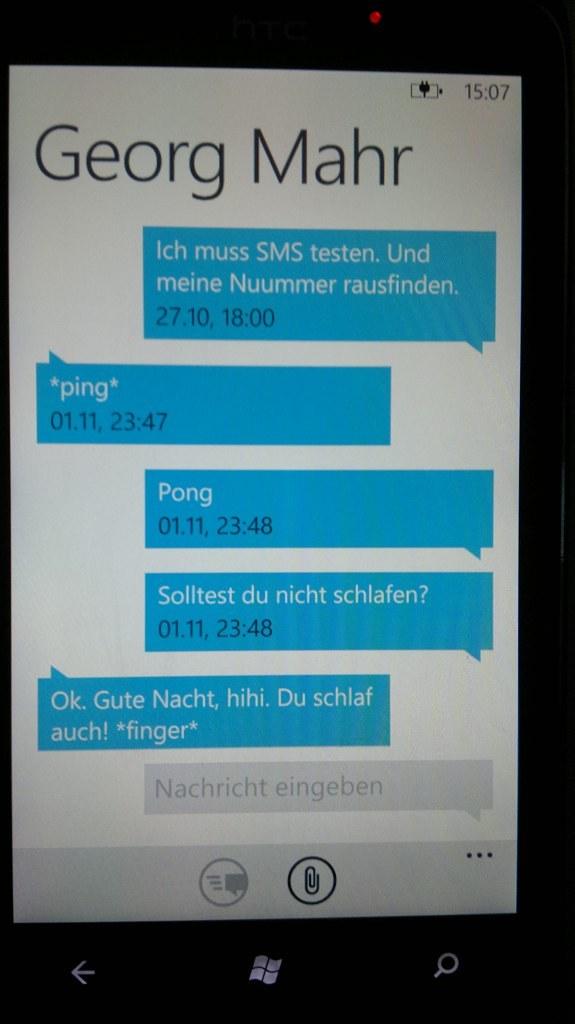Who is receiving the text messages?
Make the answer very short. Georg mahr. What is the time listed?
Give a very brief answer. 15:07. 